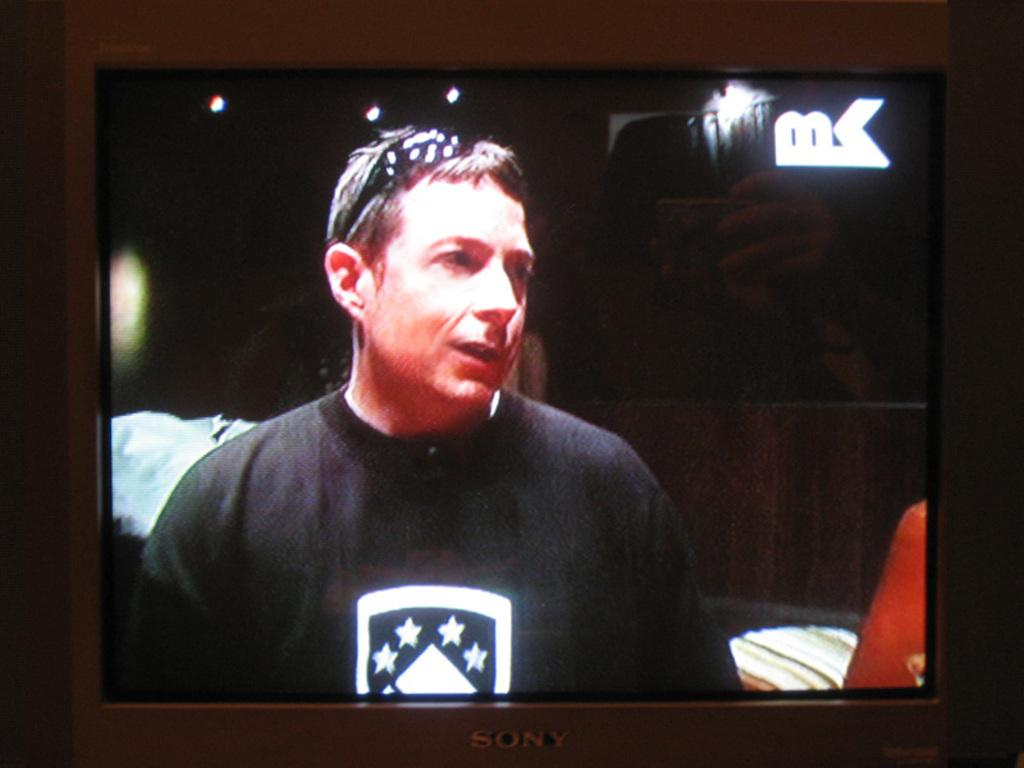What is the main object in the image? There is a television in the image. What is being displayed on the television? A person wearing a black t-shirt is displayed on the television. What type of collar can be seen on the vegetable in the image? There is no vegetable present in the image, and therefore no collar can be seen on it. 